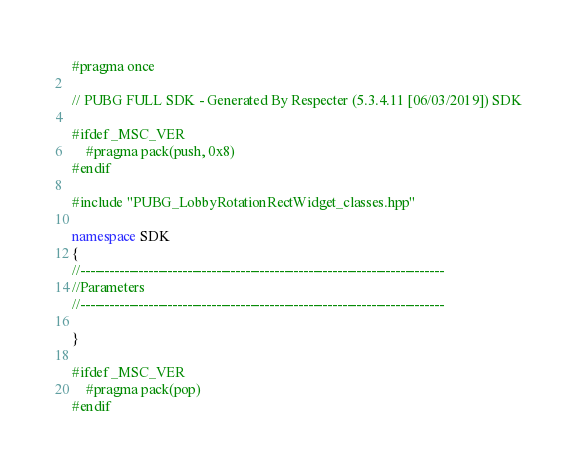Convert code to text. <code><loc_0><loc_0><loc_500><loc_500><_C++_>#pragma once

// PUBG FULL SDK - Generated By Respecter (5.3.4.11 [06/03/2019]) SDK

#ifdef _MSC_VER
	#pragma pack(push, 0x8)
#endif

#include "PUBG_LobbyRotationRectWidget_classes.hpp"

namespace SDK
{
//---------------------------------------------------------------------------
//Parameters
//---------------------------------------------------------------------------

}

#ifdef _MSC_VER
	#pragma pack(pop)
#endif
</code> 